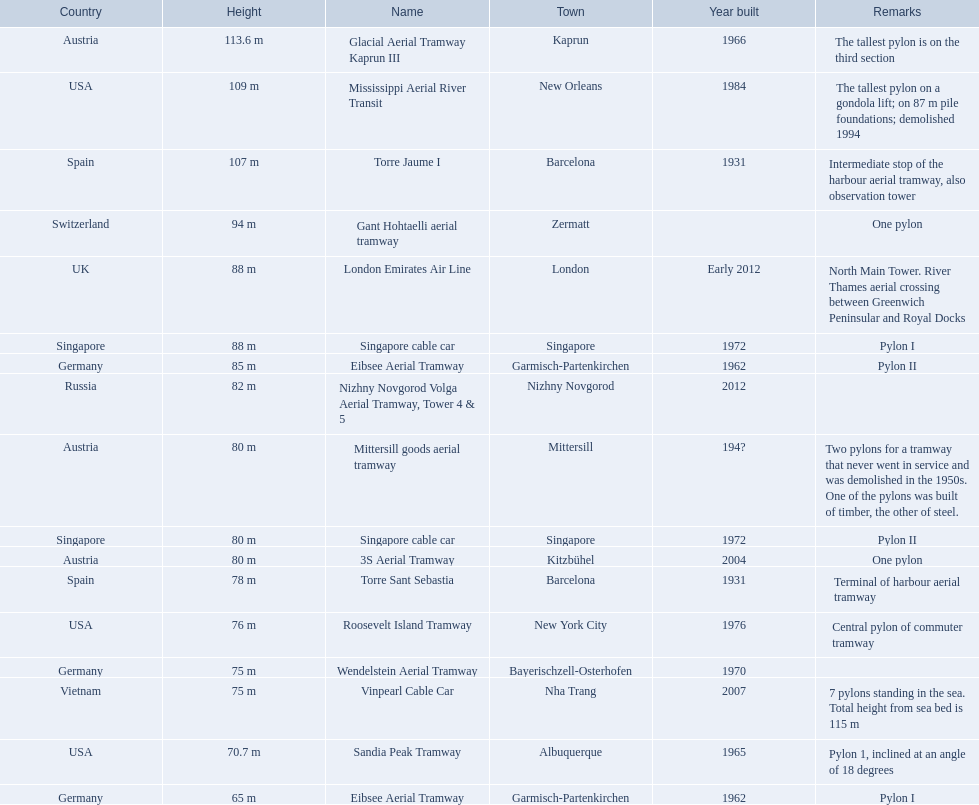Which lift has the second highest height? Mississippi Aerial River Transit. What is the value of the height? 109 m. 